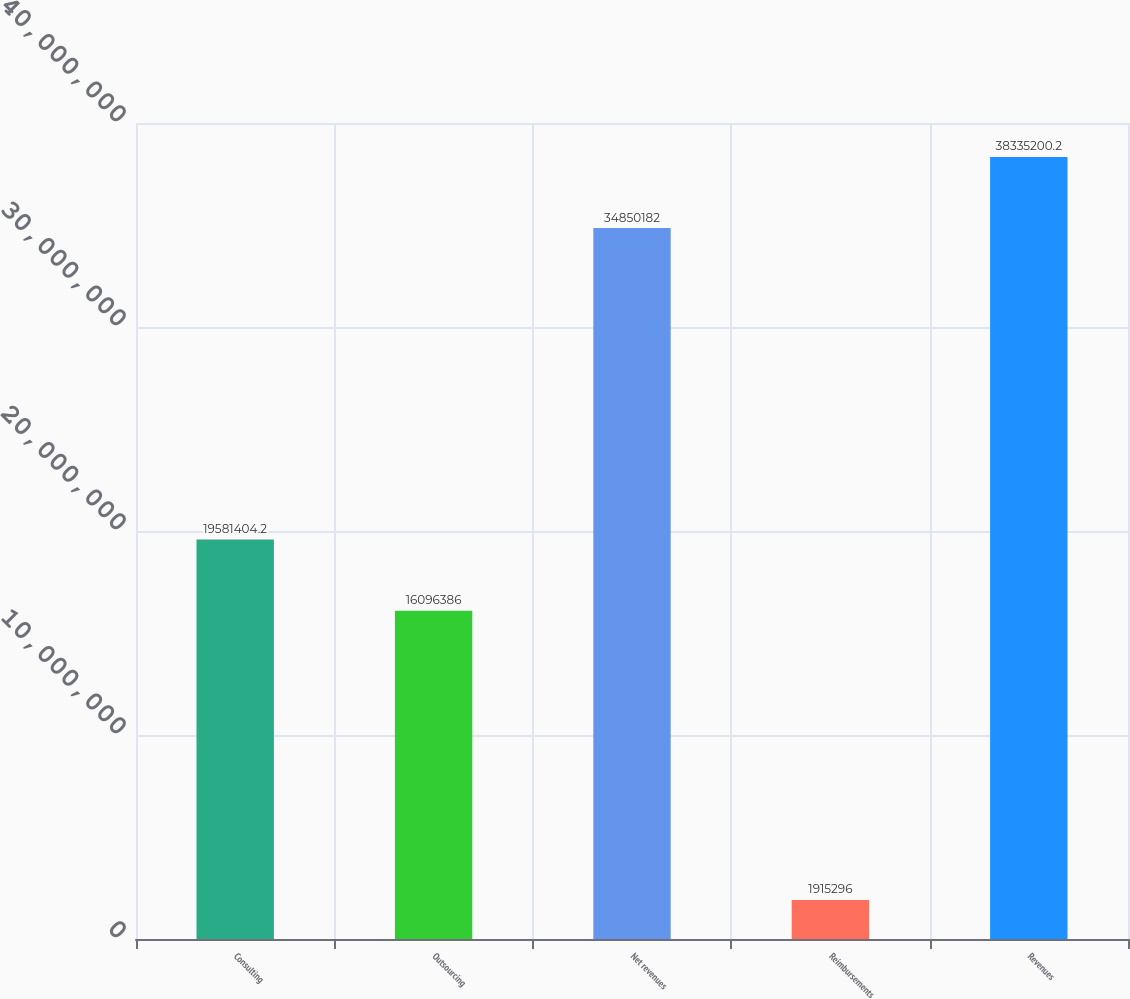Convert chart. <chart><loc_0><loc_0><loc_500><loc_500><bar_chart><fcel>Consulting<fcel>Outsourcing<fcel>Net revenues<fcel>Reimbursements<fcel>Revenues<nl><fcel>1.95814e+07<fcel>1.60964e+07<fcel>3.48502e+07<fcel>1.9153e+06<fcel>3.83352e+07<nl></chart> 